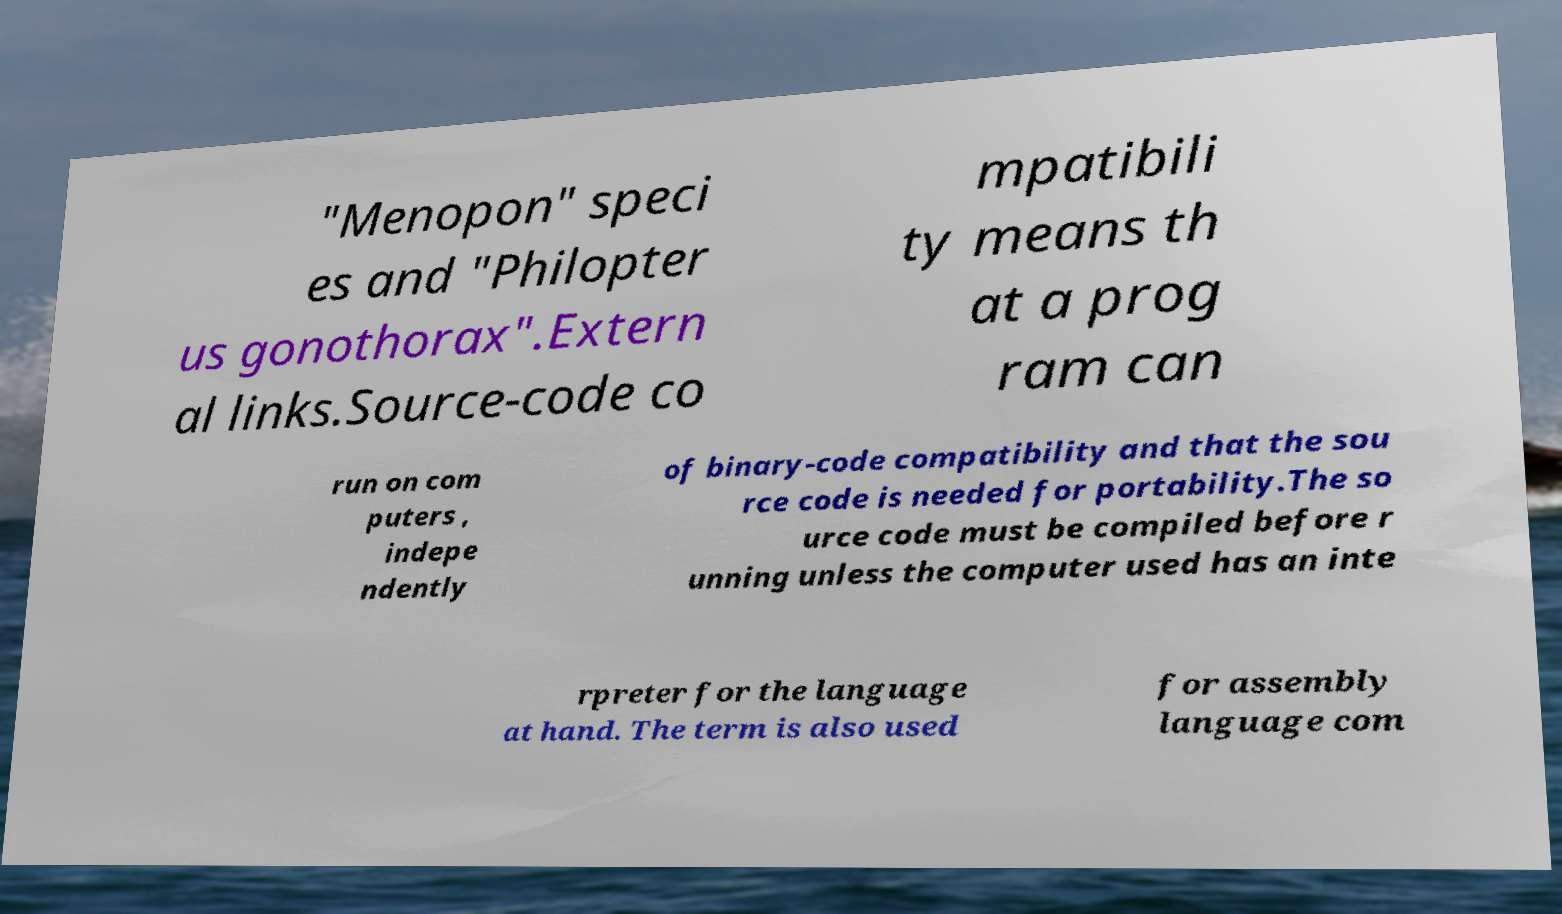For documentation purposes, I need the text within this image transcribed. Could you provide that? "Menopon" speci es and "Philopter us gonothorax".Extern al links.Source-code co mpatibili ty means th at a prog ram can run on com puters , indepe ndently of binary-code compatibility and that the sou rce code is needed for portability.The so urce code must be compiled before r unning unless the computer used has an inte rpreter for the language at hand. The term is also used for assembly language com 